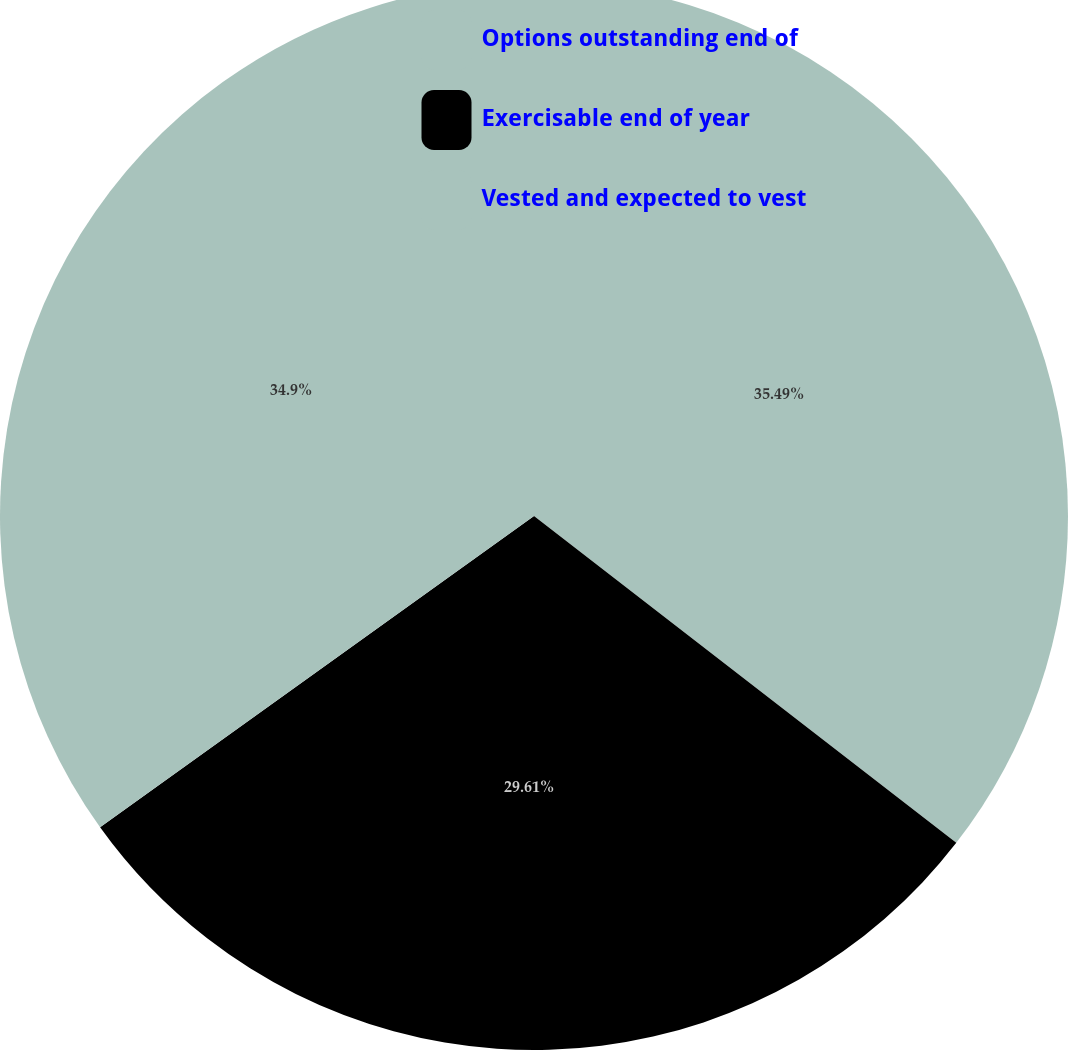Convert chart. <chart><loc_0><loc_0><loc_500><loc_500><pie_chart><fcel>Options outstanding end of<fcel>Exercisable end of year<fcel>Vested and expected to vest<nl><fcel>35.48%<fcel>29.61%<fcel>34.9%<nl></chart> 